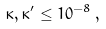Convert formula to latex. <formula><loc_0><loc_0><loc_500><loc_500>\kappa , \kappa ^ { \prime } \leq 1 0 ^ { - 8 } \, ,</formula> 